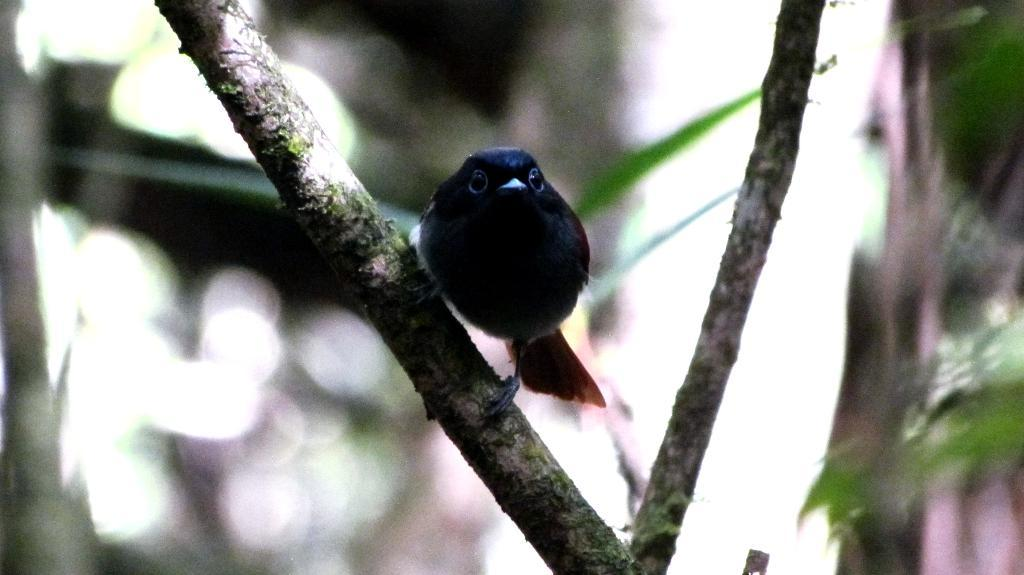What type of animal is in the image? There is a bird in the image. Where is the bird located? The bird is on a stem. What can be seen in the background of the image? There are trees visible in the background of the image. How would you describe the background of the image? The background of the image is blurred. How many roses are being held by the bird in the image? There are no roses present in the image, and the bird is not holding anything. What type of print can be seen on the bird's feathers in the image? The bird's feathers do not have any visible prints in the image. 